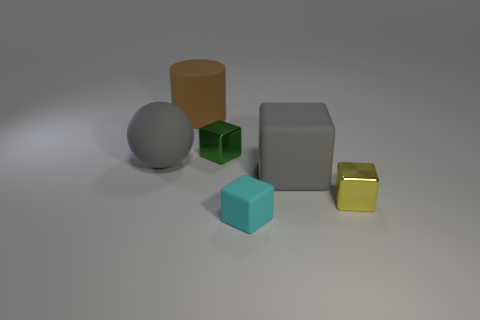There is a big block that is the same material as the large sphere; what is its color?
Make the answer very short. Gray. There is a small metal object that is to the right of the small green metallic block; what color is it?
Provide a succinct answer. Yellow. How many big matte cubes have the same color as the big cylinder?
Make the answer very short. 0. Are there fewer rubber objects behind the ball than large brown matte things left of the brown cylinder?
Provide a short and direct response. No. What number of shiny things are on the left side of the cyan block?
Offer a very short reply. 1. Is there a big thing that has the same material as the large cylinder?
Give a very brief answer. Yes. Are there more small objects that are right of the large ball than small yellow blocks behind the green thing?
Your answer should be compact. Yes. How big is the cyan rubber cube?
Provide a succinct answer. Small. What is the shape of the gray rubber thing that is on the right side of the big brown rubber object?
Make the answer very short. Cube. Does the brown object have the same shape as the small cyan thing?
Make the answer very short. No. 